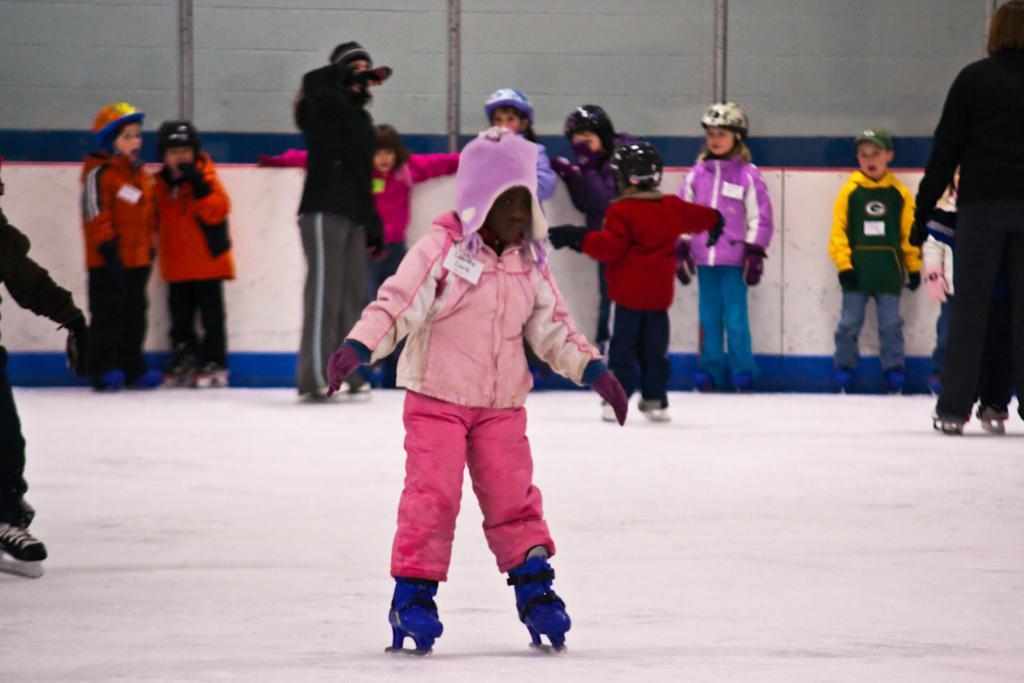How would you summarize this image in a sentence or two? In this image there is a kid skating in the snow. In the background there are so many kids who are standing in the snow by wearing the skates. 